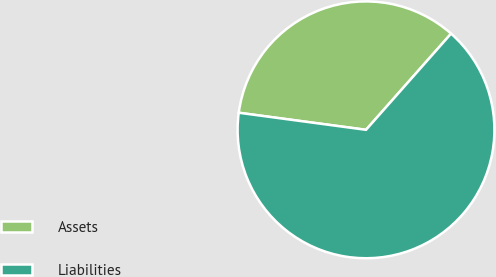Convert chart to OTSL. <chart><loc_0><loc_0><loc_500><loc_500><pie_chart><fcel>Assets<fcel>Liabilities<nl><fcel>34.4%<fcel>65.6%<nl></chart> 